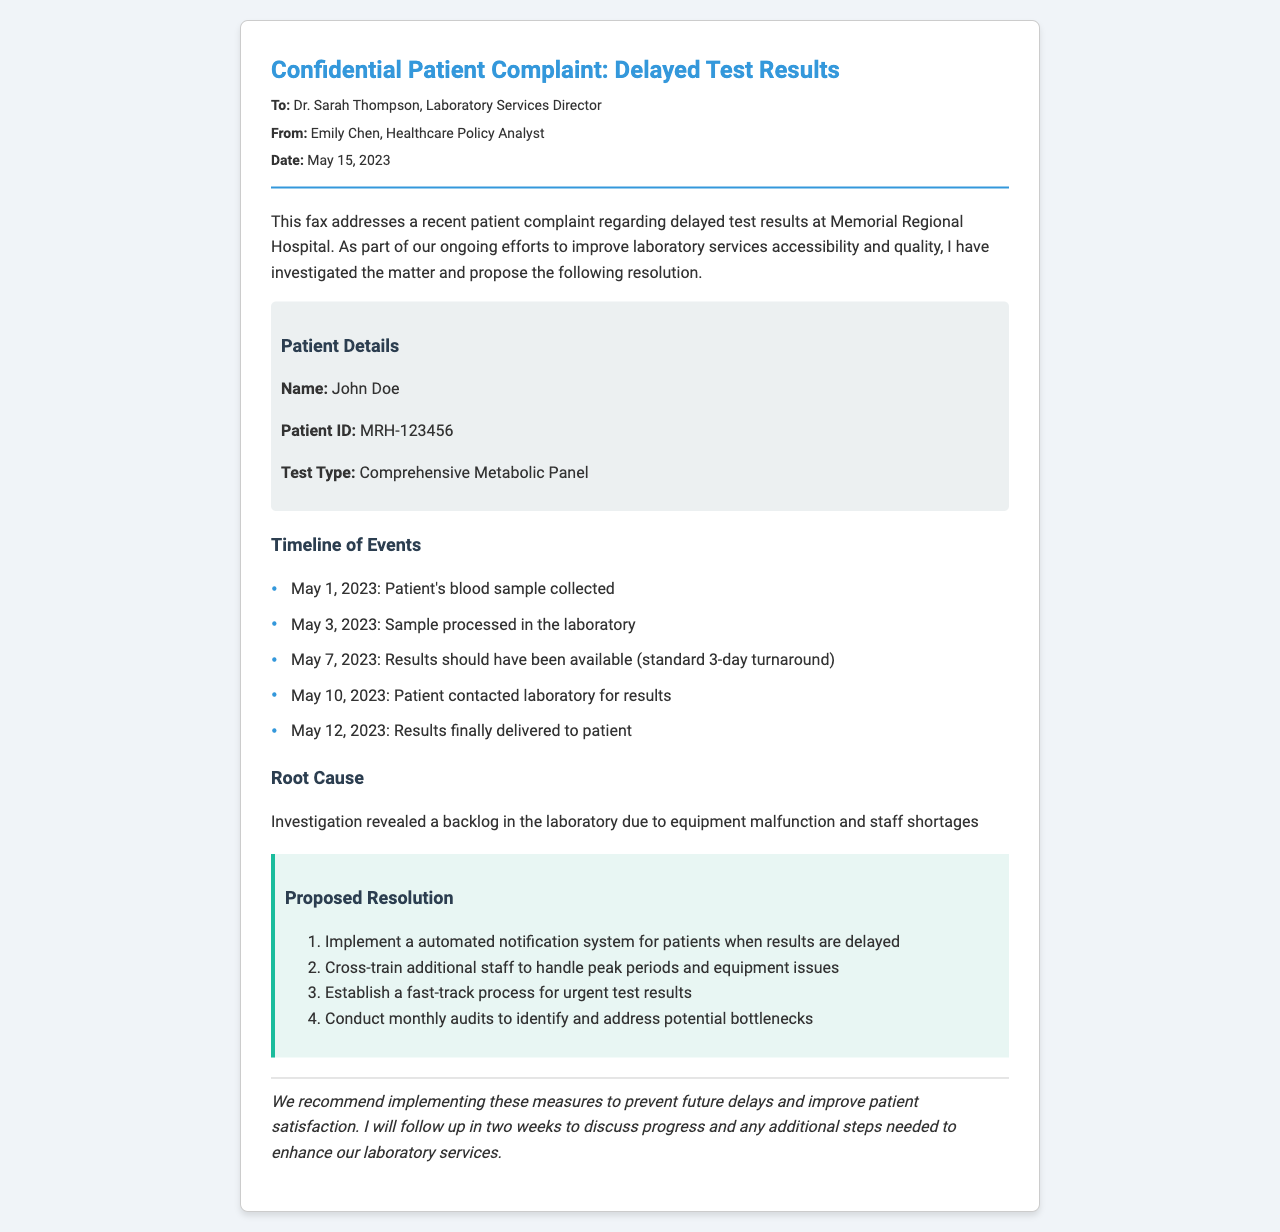What is the date of the fax? The date of the fax is explicitly mentioned in the document header.
Answer: May 15, 2023 Who is the patient mentioned in the complaint? The patient’s name is provided in the patient details section of the document.
Answer: John Doe What test type was involved in the complaint? The type of test is specified in the patient details.
Answer: Comprehensive Metabolic Panel On what date should the results have been available? The expected date for the results to be available is listed in the timeline of events.
Answer: May 7, 2023 What was the root cause identified for the delayed results? The document states the root cause in the root cause section following the timeline.
Answer: Equipment malfunction and staff shortages How long did it take for the results to reach the patient after the sample was collected? The timeline shows the days between the sample collection and results delivery to determine the total time.
Answer: 11 days What is one of the proposed resolutions for the issue? The proposed resolutions are outlined in the proposed resolution section.
Answer: Implement a automated notification system What is the name of the sender of the fax? The sender's name is listed at the top of the document.
Answer: Emily Chen How did the patient first contact the laboratory? The timeline indicates the means of contact by the patient to obtain results.
Answer: By phone 